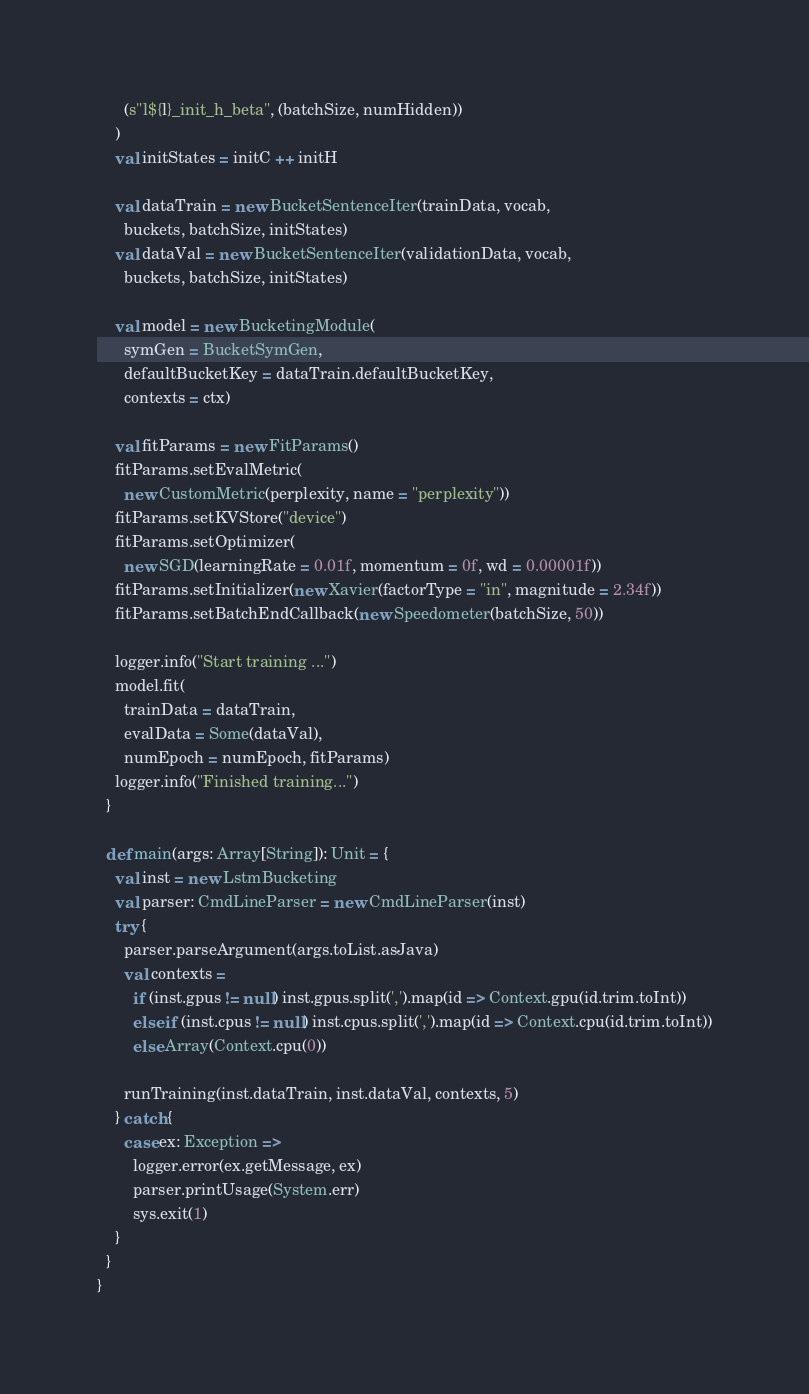Convert code to text. <code><loc_0><loc_0><loc_500><loc_500><_Scala_>      (s"l${l}_init_h_beta", (batchSize, numHidden))
    )
    val initStates = initC ++ initH

    val dataTrain = new BucketSentenceIter(trainData, vocab,
      buckets, batchSize, initStates)
    val dataVal = new BucketSentenceIter(validationData, vocab,
      buckets, batchSize, initStates)

    val model = new BucketingModule(
      symGen = BucketSymGen,
      defaultBucketKey = dataTrain.defaultBucketKey,
      contexts = ctx)

    val fitParams = new FitParams()
    fitParams.setEvalMetric(
      new CustomMetric(perplexity, name = "perplexity"))
    fitParams.setKVStore("device")
    fitParams.setOptimizer(
      new SGD(learningRate = 0.01f, momentum = 0f, wd = 0.00001f))
    fitParams.setInitializer(new Xavier(factorType = "in", magnitude = 2.34f))
    fitParams.setBatchEndCallback(new Speedometer(batchSize, 50))

    logger.info("Start training ...")
    model.fit(
      trainData = dataTrain,
      evalData = Some(dataVal),
      numEpoch = numEpoch, fitParams)
    logger.info("Finished training...")
  }

  def main(args: Array[String]): Unit = {
    val inst = new LstmBucketing
    val parser: CmdLineParser = new CmdLineParser(inst)
    try {
      parser.parseArgument(args.toList.asJava)
      val contexts =
        if (inst.gpus != null) inst.gpus.split(',').map(id => Context.gpu(id.trim.toInt))
        else if (inst.cpus != null) inst.cpus.split(',').map(id => Context.cpu(id.trim.toInt))
        else Array(Context.cpu(0))

      runTraining(inst.dataTrain, inst.dataVal, contexts, 5)
    } catch {
      case ex: Exception =>
        logger.error(ex.getMessage, ex)
        parser.printUsage(System.err)
        sys.exit(1)
    }
  }
}
</code> 